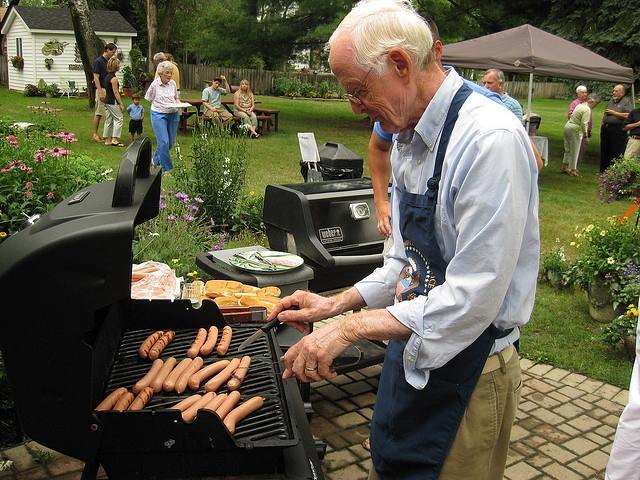Describe the objects in this image and their specific colors. I can see people in darkgreen, darkgray, lightgray, black, and olive tones, people in darkgreen, black, lightgray, and tan tones, umbrella in darkgreen, darkgray, and gray tones, potted plant in darkgreen, black, and olive tones, and hot dog in darkgreen, black, tan, brown, and salmon tones in this image. 